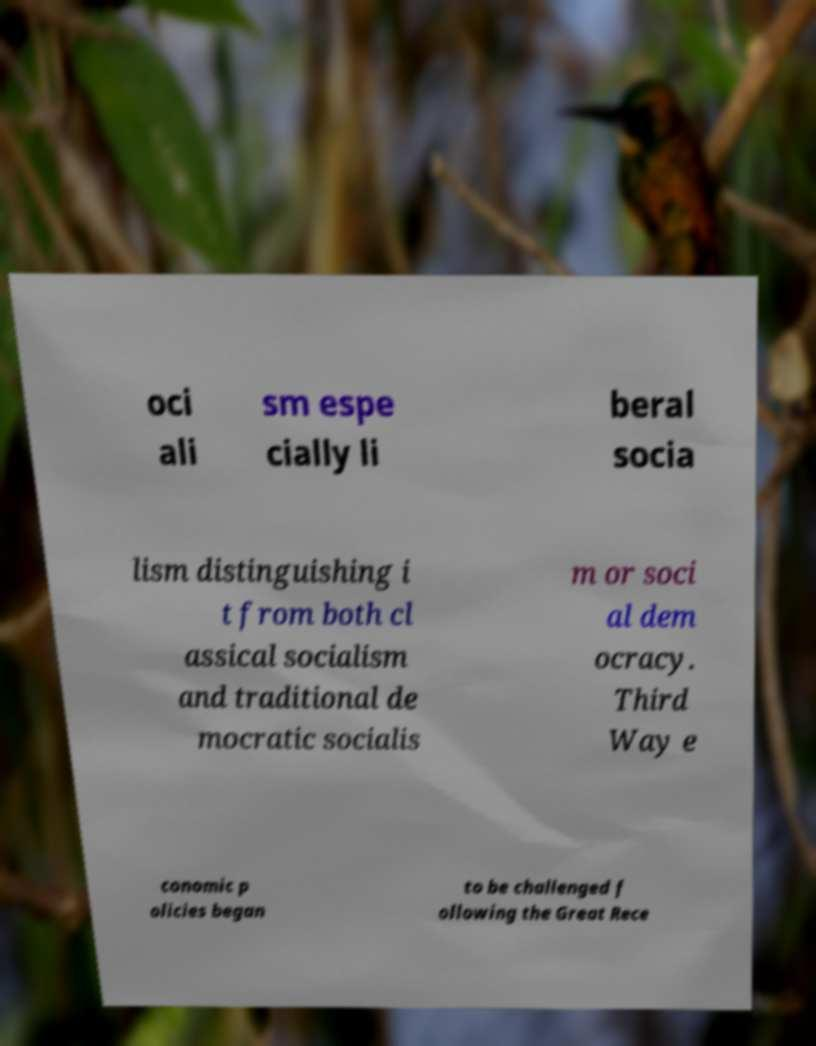For documentation purposes, I need the text within this image transcribed. Could you provide that? oci ali sm espe cially li beral socia lism distinguishing i t from both cl assical socialism and traditional de mocratic socialis m or soci al dem ocracy. Third Way e conomic p olicies began to be challenged f ollowing the Great Rece 